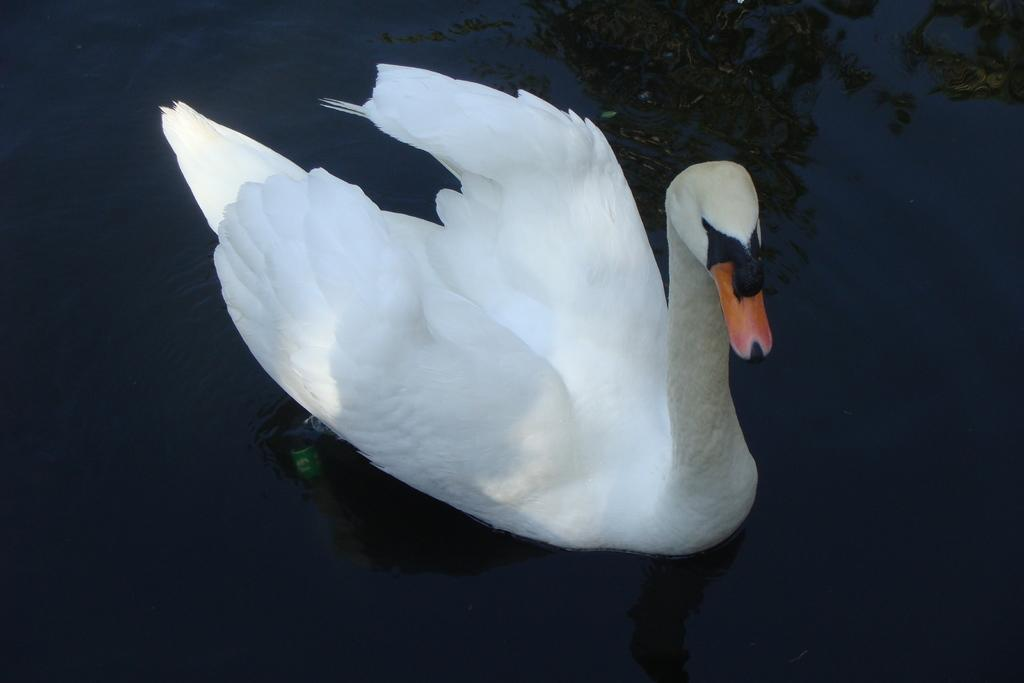What type of animal can be seen in the image? There is a bird in the image. Where is the bird located in the image? The bird is on the water. What colors can be observed on the bird? The bird has white, black, and brown colors. What type of skate is the bird using to navigate the water in the image? There is no skate present in the image, and the bird is not using any device to navigate the water. 